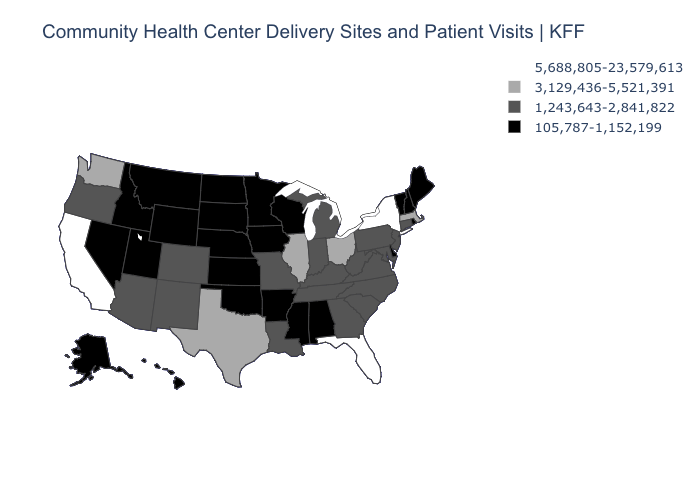Which states hav the highest value in the South?
Give a very brief answer. Florida. Which states hav the highest value in the West?
Short answer required. California. Does Louisiana have the highest value in the USA?
Answer briefly. No. What is the value of North Dakota?
Short answer required. 105,787-1,152,199. Name the states that have a value in the range 5,688,805-23,579,613?
Short answer required. California, Florida, New York. Name the states that have a value in the range 1,243,643-2,841,822?
Answer briefly. Arizona, Colorado, Connecticut, Georgia, Indiana, Kentucky, Louisiana, Maryland, Michigan, Missouri, New Jersey, New Mexico, North Carolina, Oregon, Pennsylvania, South Carolina, Tennessee, Virginia, West Virginia. What is the highest value in the USA?
Give a very brief answer. 5,688,805-23,579,613. Name the states that have a value in the range 5,688,805-23,579,613?
Write a very short answer. California, Florida, New York. Does the first symbol in the legend represent the smallest category?
Short answer required. No. What is the value of Maryland?
Concise answer only. 1,243,643-2,841,822. What is the lowest value in the USA?
Answer briefly. 105,787-1,152,199. What is the value of Nebraska?
Keep it brief. 105,787-1,152,199. What is the value of Georgia?
Keep it brief. 1,243,643-2,841,822. Name the states that have a value in the range 3,129,436-5,521,391?
Quick response, please. Illinois, Massachusetts, Ohio, Texas, Washington. Does West Virginia have the lowest value in the USA?
Concise answer only. No. 